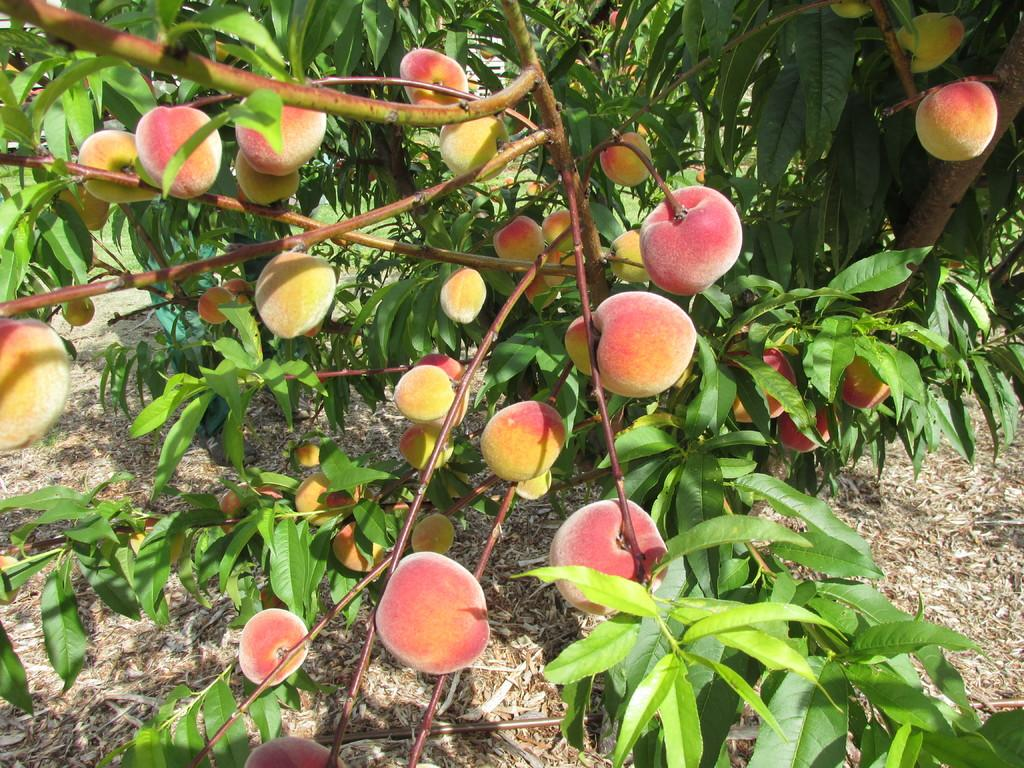What is the main object in the image? There is a tree in the image. Can you describe the tree in more detail? The tree has branches with fruits and leaves. Are there any people in the image? Yes, two persons are standing on the land on the left side of the image. What type of paper can be seen on the tree in the image? There is no paper present on the tree in the image; it has branches with fruits and leaves. 